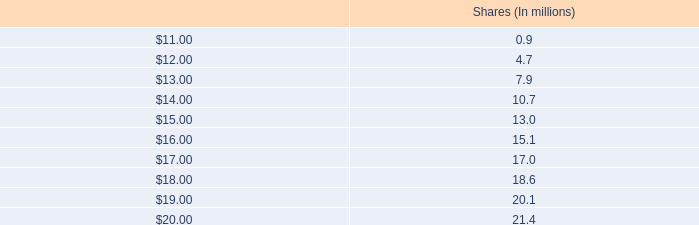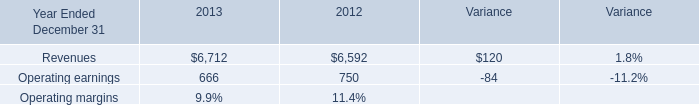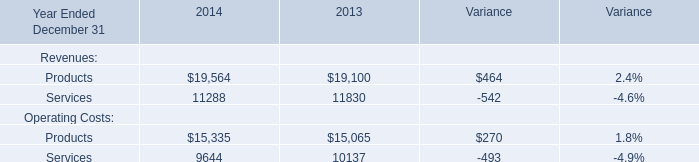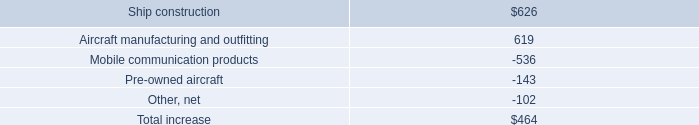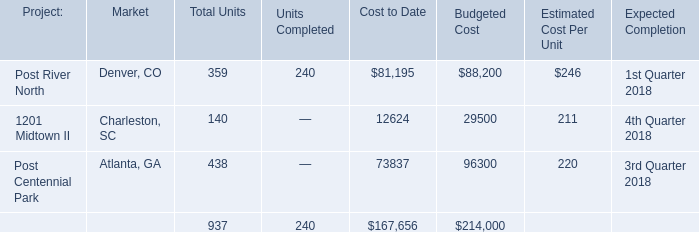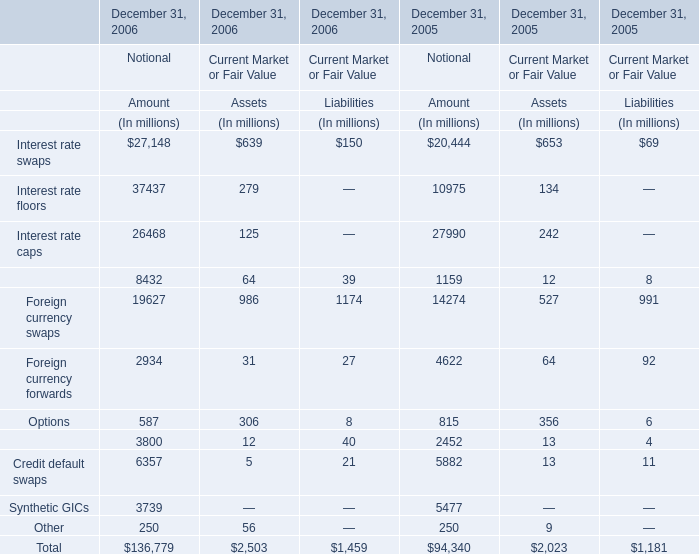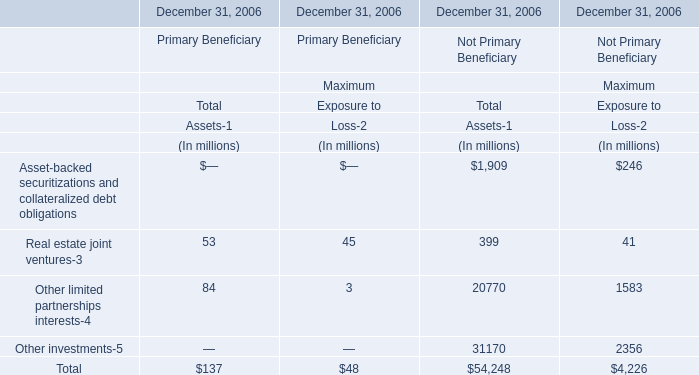What do all Maximum of Primary Beneficiary sum up, excluding those negative ones in 2006? (in million) 
Computations: (45 + 3)
Answer: 48.0. 